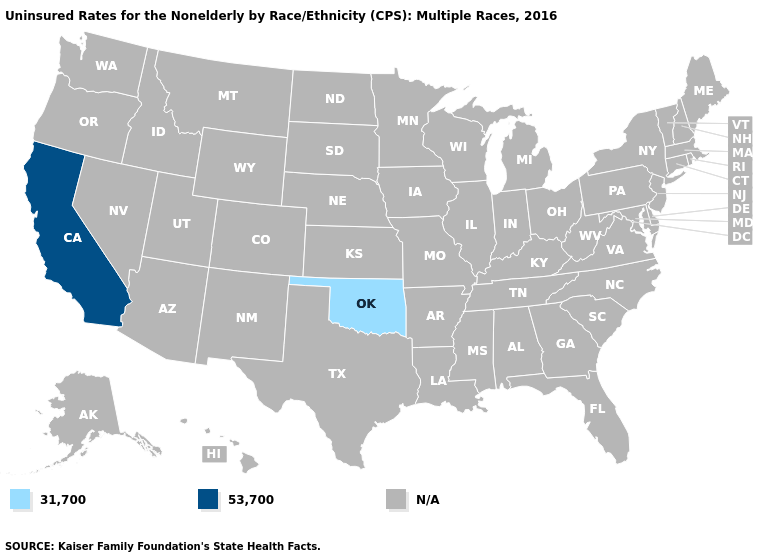What is the value of Maine?
Keep it brief. N/A. Name the states that have a value in the range 31,700?
Give a very brief answer. Oklahoma. Name the states that have a value in the range 53,700?
Be succinct. California. What is the lowest value in states that border Texas?
Quick response, please. 31,700. What is the lowest value in states that border Arizona?
Quick response, please. 53,700. Does California have the lowest value in the USA?
Be succinct. No. Name the states that have a value in the range N/A?
Answer briefly. Alabama, Alaska, Arizona, Arkansas, Colorado, Connecticut, Delaware, Florida, Georgia, Hawaii, Idaho, Illinois, Indiana, Iowa, Kansas, Kentucky, Louisiana, Maine, Maryland, Massachusetts, Michigan, Minnesota, Mississippi, Missouri, Montana, Nebraska, Nevada, New Hampshire, New Jersey, New Mexico, New York, North Carolina, North Dakota, Ohio, Oregon, Pennsylvania, Rhode Island, South Carolina, South Dakota, Tennessee, Texas, Utah, Vermont, Virginia, Washington, West Virginia, Wisconsin, Wyoming. Does the first symbol in the legend represent the smallest category?
Concise answer only. Yes. Name the states that have a value in the range 53,700?
Write a very short answer. California. Does the map have missing data?
Answer briefly. Yes. Name the states that have a value in the range N/A?
Concise answer only. Alabama, Alaska, Arizona, Arkansas, Colorado, Connecticut, Delaware, Florida, Georgia, Hawaii, Idaho, Illinois, Indiana, Iowa, Kansas, Kentucky, Louisiana, Maine, Maryland, Massachusetts, Michigan, Minnesota, Mississippi, Missouri, Montana, Nebraska, Nevada, New Hampshire, New Jersey, New Mexico, New York, North Carolina, North Dakota, Ohio, Oregon, Pennsylvania, Rhode Island, South Carolina, South Dakota, Tennessee, Texas, Utah, Vermont, Virginia, Washington, West Virginia, Wisconsin, Wyoming. 